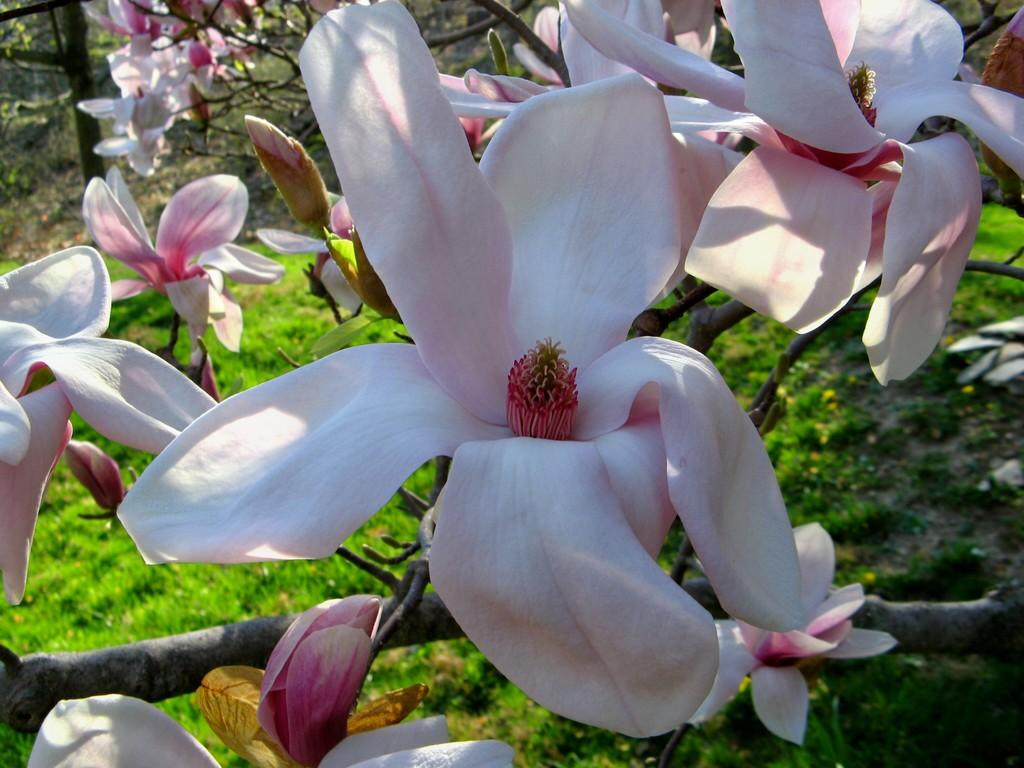What is present in the foreground of the image? There are flowers in the foreground of the image. What is present in the background of the image? There are flowers and trees in the background of the image. What type of vegetation is at the bottom of the image? There is grass at the bottom of the image. How many tickets can be seen in the image? There are no tickets present in the image. What type of cannon is visible in the image? There is no cannon present in the image. 